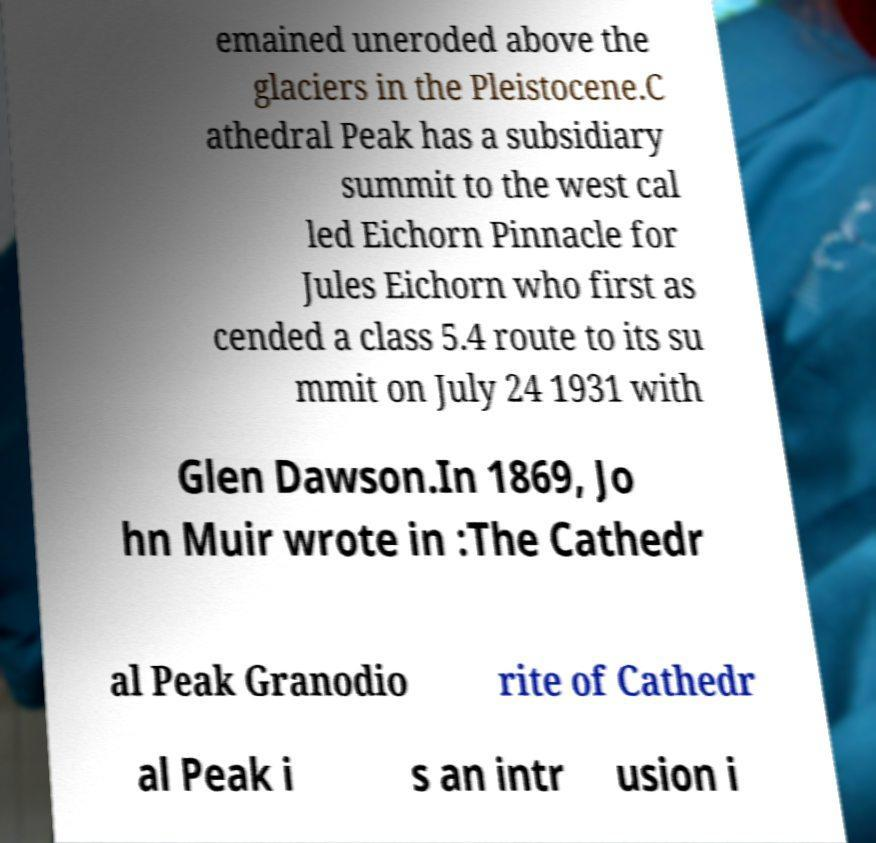What messages or text are displayed in this image? I need them in a readable, typed format. emained uneroded above the glaciers in the Pleistocene.C athedral Peak has a subsidiary summit to the west cal led Eichorn Pinnacle for Jules Eichorn who first as cended a class 5.4 route to its su mmit on July 24 1931 with Glen Dawson.In 1869, Jo hn Muir wrote in :The Cathedr al Peak Granodio rite of Cathedr al Peak i s an intr usion i 